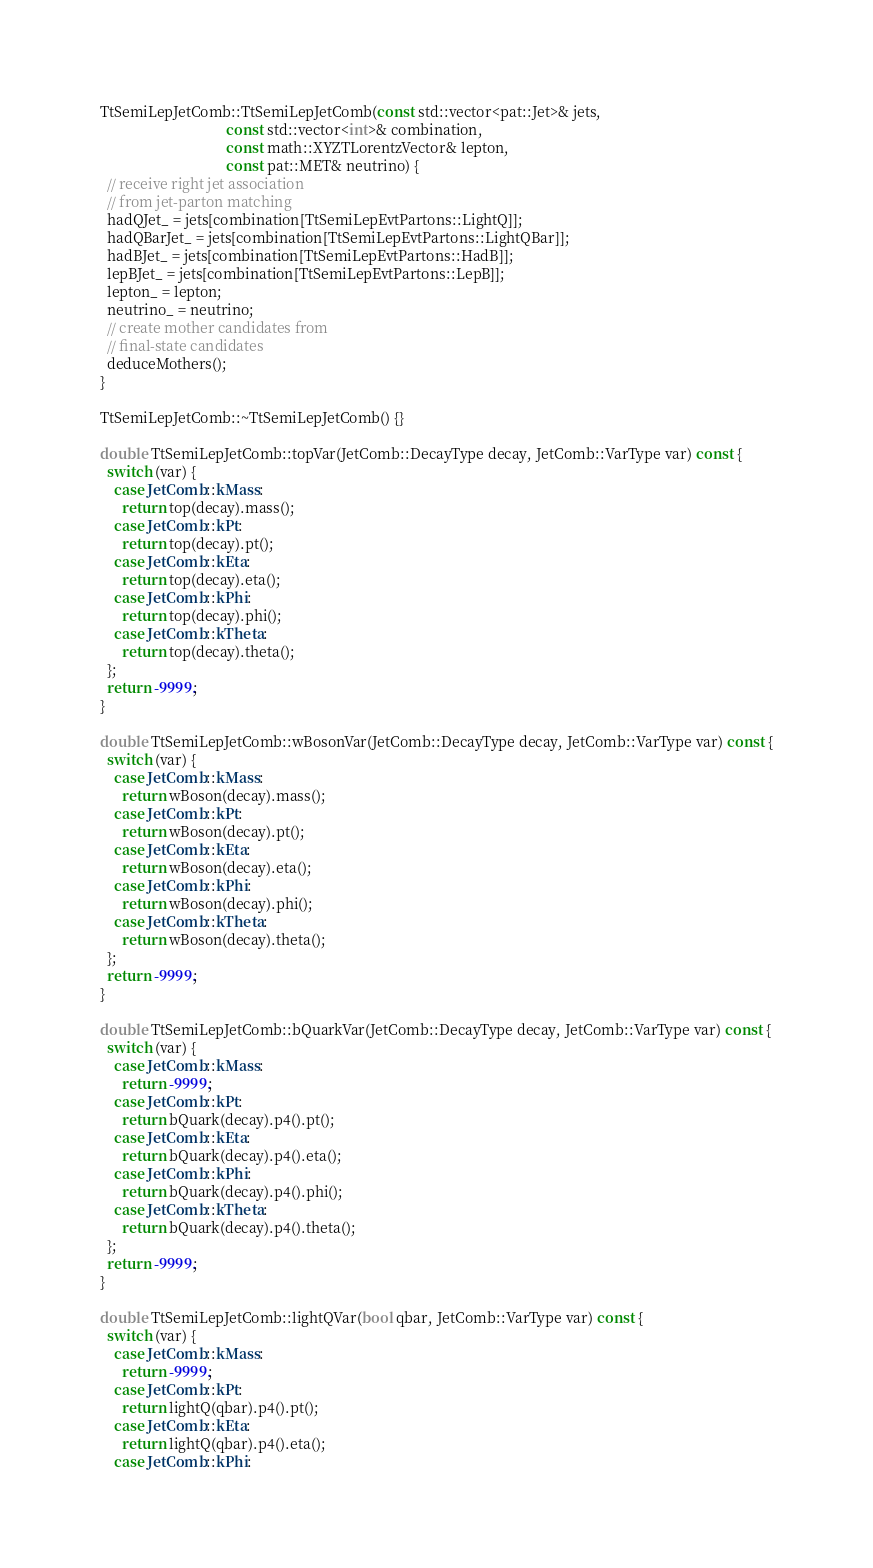Convert code to text. <code><loc_0><loc_0><loc_500><loc_500><_C++_>TtSemiLepJetComb::TtSemiLepJetComb(const std::vector<pat::Jet>& jets,
                                   const std::vector<int>& combination,
                                   const math::XYZTLorentzVector& lepton,
                                   const pat::MET& neutrino) {
  // receive right jet association
  // from jet-parton matching
  hadQJet_ = jets[combination[TtSemiLepEvtPartons::LightQ]];
  hadQBarJet_ = jets[combination[TtSemiLepEvtPartons::LightQBar]];
  hadBJet_ = jets[combination[TtSemiLepEvtPartons::HadB]];
  lepBJet_ = jets[combination[TtSemiLepEvtPartons::LepB]];
  lepton_ = lepton;
  neutrino_ = neutrino;
  // create mother candidates from
  // final-state candidates
  deduceMothers();
}

TtSemiLepJetComb::~TtSemiLepJetComb() {}

double TtSemiLepJetComb::topVar(JetComb::DecayType decay, JetComb::VarType var) const {
  switch (var) {
    case JetComb::kMass:
      return top(decay).mass();
    case JetComb::kPt:
      return top(decay).pt();
    case JetComb::kEta:
      return top(decay).eta();
    case JetComb::kPhi:
      return top(decay).phi();
    case JetComb::kTheta:
      return top(decay).theta();
  };
  return -9999.;
}

double TtSemiLepJetComb::wBosonVar(JetComb::DecayType decay, JetComb::VarType var) const {
  switch (var) {
    case JetComb::kMass:
      return wBoson(decay).mass();
    case JetComb::kPt:
      return wBoson(decay).pt();
    case JetComb::kEta:
      return wBoson(decay).eta();
    case JetComb::kPhi:
      return wBoson(decay).phi();
    case JetComb::kTheta:
      return wBoson(decay).theta();
  };
  return -9999.;
}

double TtSemiLepJetComb::bQuarkVar(JetComb::DecayType decay, JetComb::VarType var) const {
  switch (var) {
    case JetComb::kMass:
      return -9999.;
    case JetComb::kPt:
      return bQuark(decay).p4().pt();
    case JetComb::kEta:
      return bQuark(decay).p4().eta();
    case JetComb::kPhi:
      return bQuark(decay).p4().phi();
    case JetComb::kTheta:
      return bQuark(decay).p4().theta();
  };
  return -9999.;
}

double TtSemiLepJetComb::lightQVar(bool qbar, JetComb::VarType var) const {
  switch (var) {
    case JetComb::kMass:
      return -9999.;
    case JetComb::kPt:
      return lightQ(qbar).p4().pt();
    case JetComb::kEta:
      return lightQ(qbar).p4().eta();
    case JetComb::kPhi:</code> 